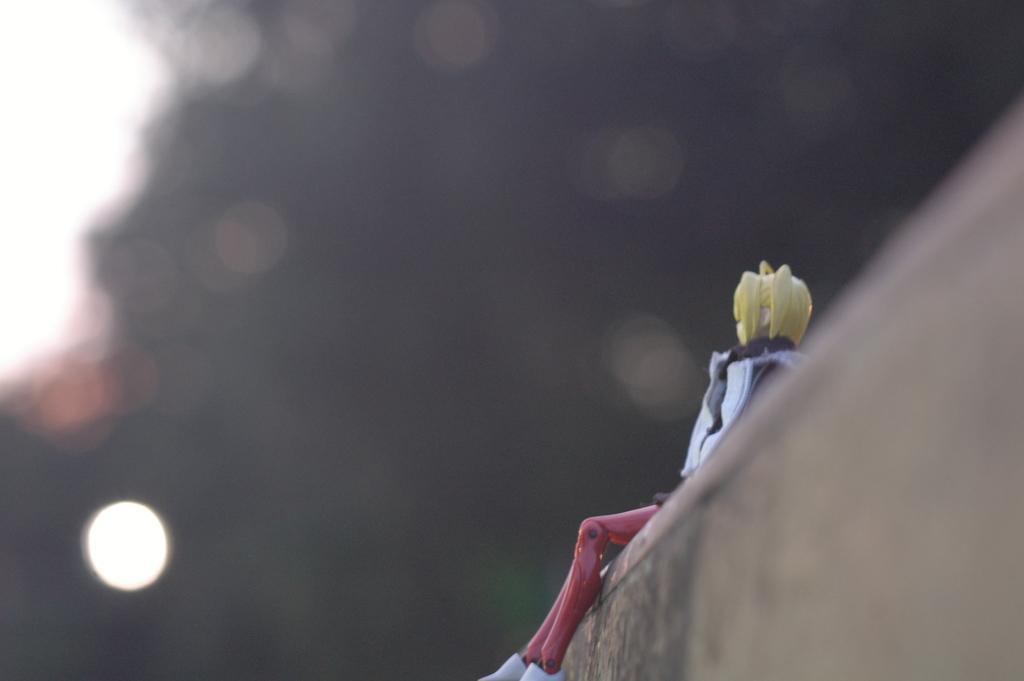How would you summarize this image in a sentence or two? In this image we can see a doll on the wall. In the background there are lights. 